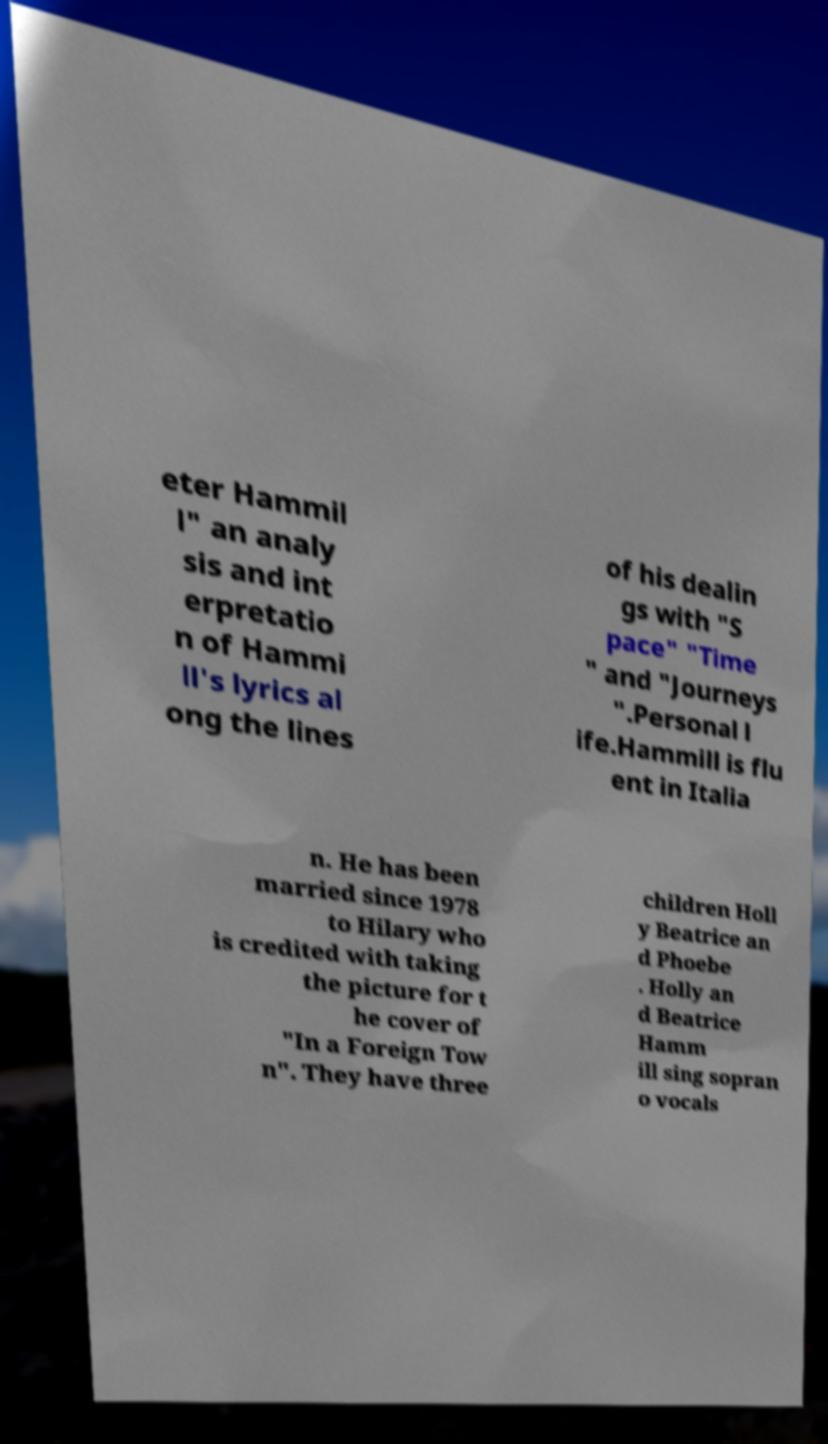Could you assist in decoding the text presented in this image and type it out clearly? eter Hammil l" an analy sis and int erpretatio n of Hammi ll's lyrics al ong the lines of his dealin gs with "S pace" "Time " and "Journeys ".Personal l ife.Hammill is flu ent in Italia n. He has been married since 1978 to Hilary who is credited with taking the picture for t he cover of "In a Foreign Tow n". They have three children Holl y Beatrice an d Phoebe . Holly an d Beatrice Hamm ill sing sopran o vocals 